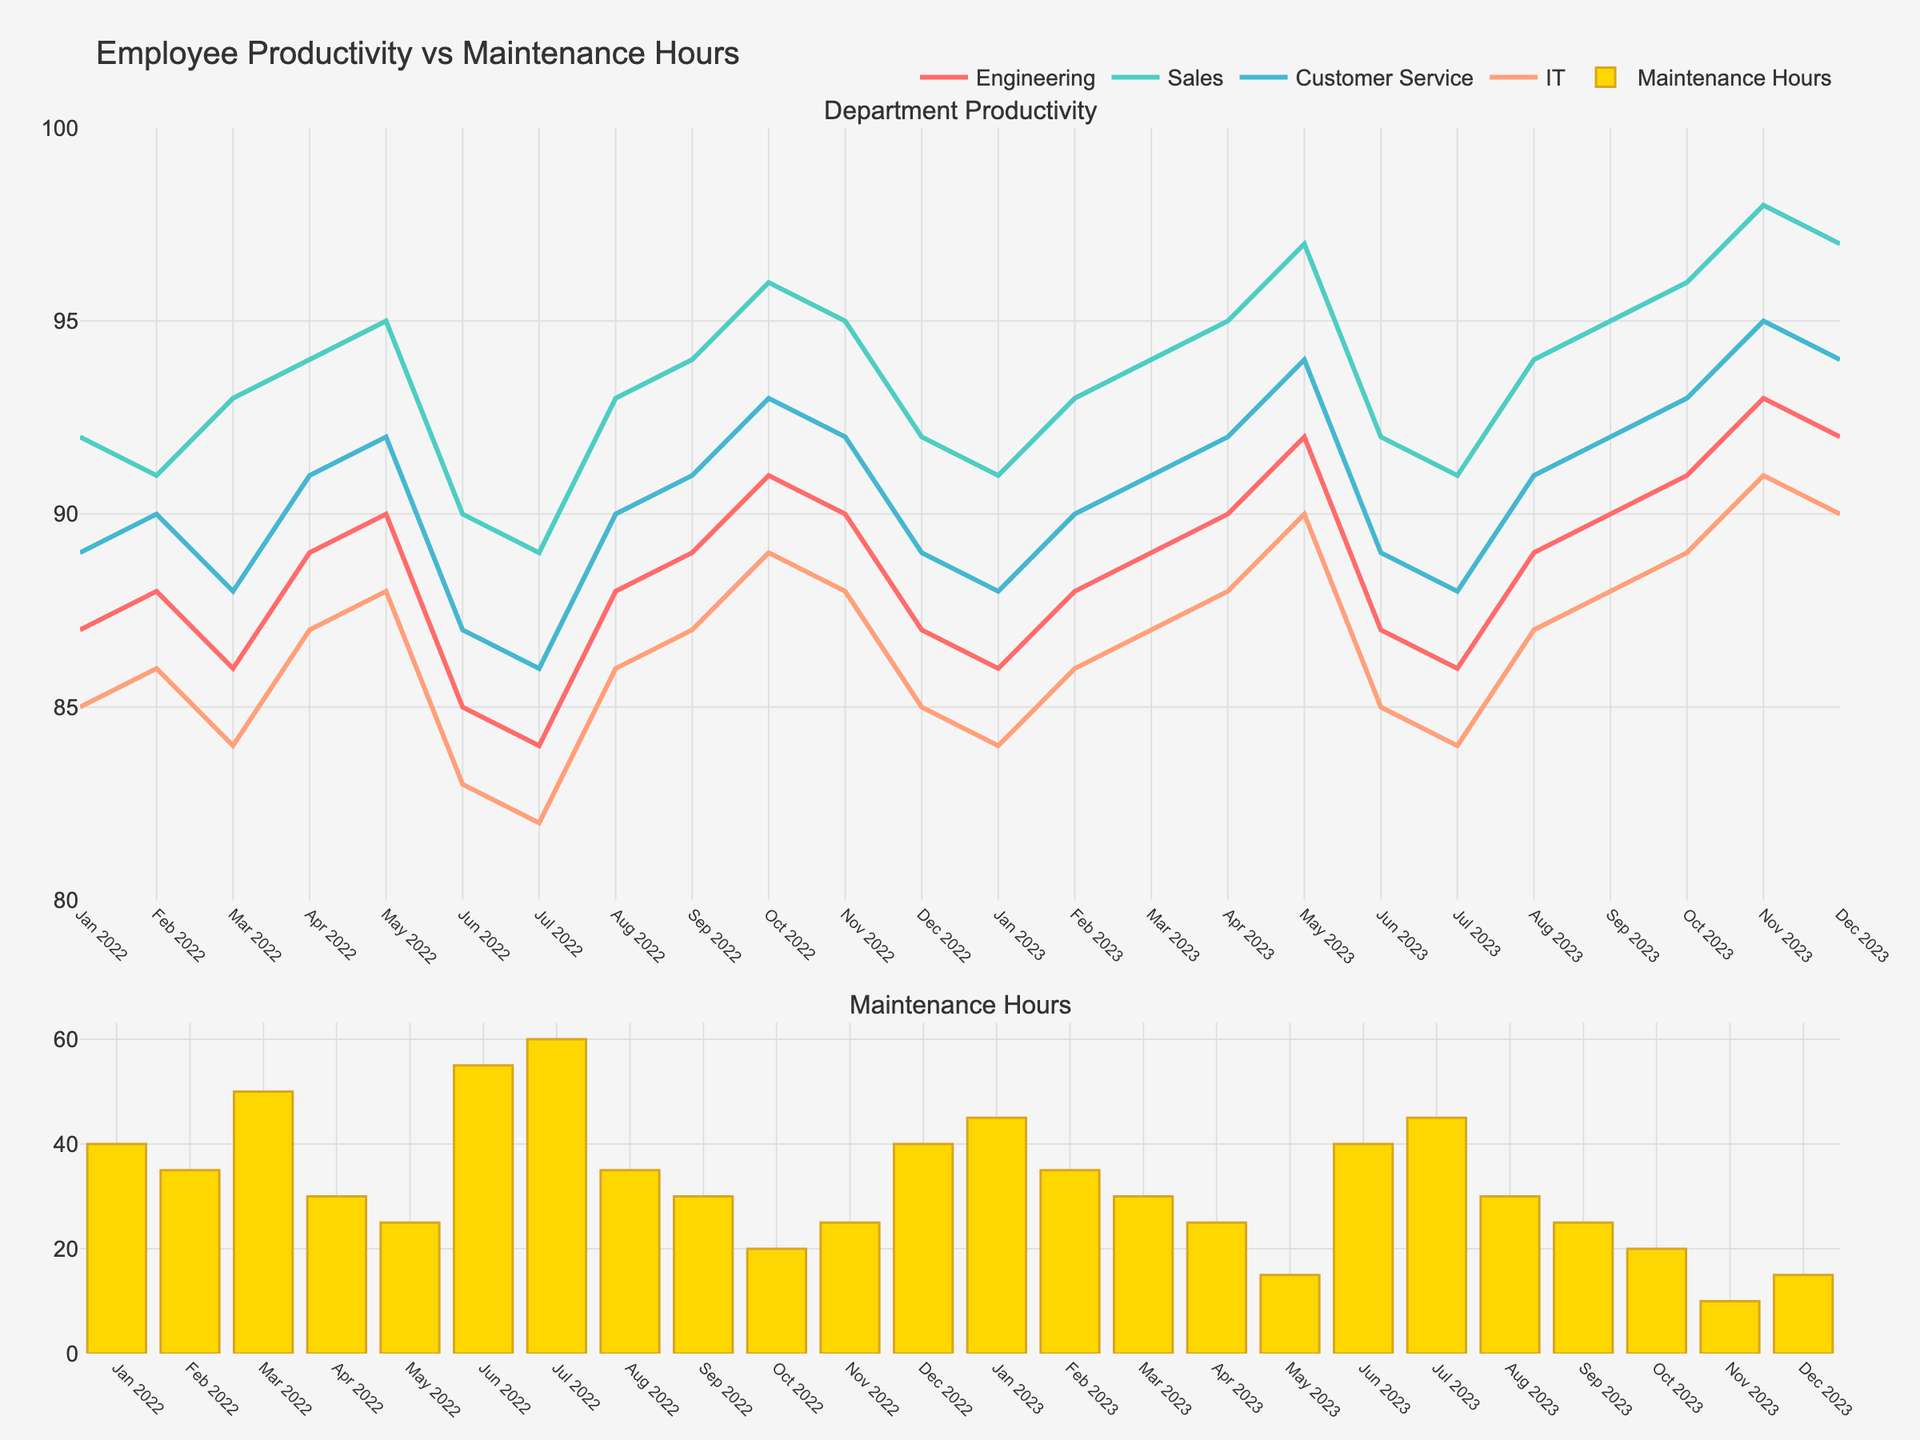How many companies are analyzed in the figure? The plot is divided into four subplots, each representing a different company. The titles of the subplots indicate the names of the companies.
Answer: 4 What is the general trend observed in each subplot? By examining the plots, we notice that as CSR investment increases over time for each company, the public perception scores also tend to increase. This indicates a positive correlation.
Answer: Positive correlation Which company had the highest CSR investment in 2021? Looking at the data points labeled with the year 2021 in the subplot, the company with the highest CSR investment is Microsoft, with an investment of 198 million USD.
Answer: Microsoft Compare the public perception score of Nike and Unilever in 2021. In the subplots for Nike and Unilever, the data points labeled with 2021 indicate their public perception scores. Nike has a score of 73, while Unilever has a score of 79.
Answer: Unilever What is the CSR investment range for Coca-Cola from 2018 to 2021? By observing the x-axis values in Coca-Cola's subplot, the CSR investments range from 50 million USD to 72 million USD.
Answer: 50-72 million USD Which company shows the steepest increase in public perception scores over the years? By comparing the slopes of the lines connecting the data points for each company, Microsoft's subplot reveals the steepest increase from 72 to 83.
Answer: Microsoft What year had notable jumps in CSR investment for most companies? Observing the subplots, 2021 stands out as the year where most companies show a considerable increase in CSR investment compared to previous years.
Answer: 2021 Which company had the lowest starting public perception score in 2018? The subplots reveal that Nike had the lowest public perception score of 65 in 2018, among the four companies.
Answer: Nike Is there any year labeled as an outlier in terms of relationship between CSR investment and public perception score? Reviewing the subplots carefully, no year appears as an outlier; all data points generally follow the positive correlation trend.
Answer: No What is the change in public perception score for Unilever from 2018 to 2021? From the subplot for Unilever, the score increases from 71 in 2018 to 79 in 2021. Calculating the difference: 79 - 71 = 8.
Answer: 8 